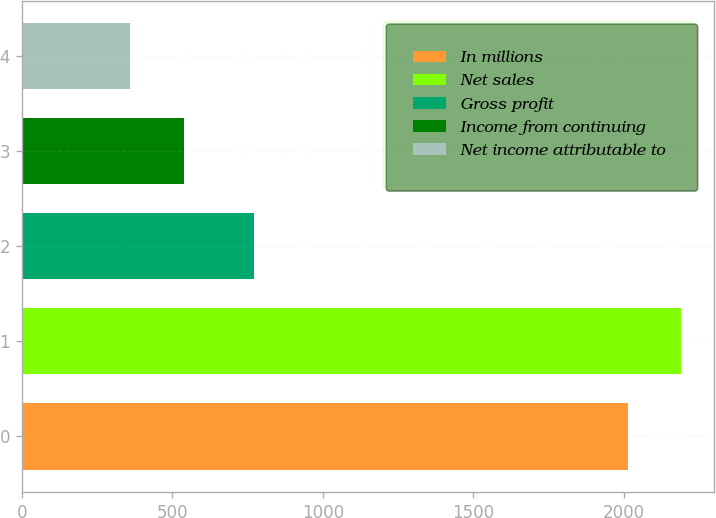<chart> <loc_0><loc_0><loc_500><loc_500><bar_chart><fcel>In millions<fcel>Net sales<fcel>Gross profit<fcel>Income from continuing<fcel>Net income attributable to<nl><fcel>2014<fcel>2191.8<fcel>772<fcel>537.8<fcel>360<nl></chart> 